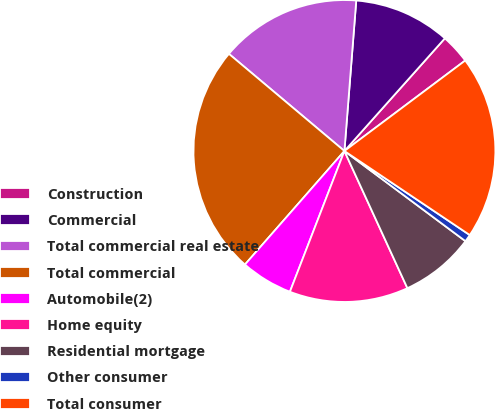Convert chart. <chart><loc_0><loc_0><loc_500><loc_500><pie_chart><fcel>Construction<fcel>Commercial<fcel>Total commercial real estate<fcel>Total commercial<fcel>Automobile(2)<fcel>Home equity<fcel>Residential mortgage<fcel>Other consumer<fcel>Total consumer<nl><fcel>3.18%<fcel>10.34%<fcel>15.12%<fcel>24.68%<fcel>5.57%<fcel>12.73%<fcel>7.96%<fcel>0.79%<fcel>19.63%<nl></chart> 